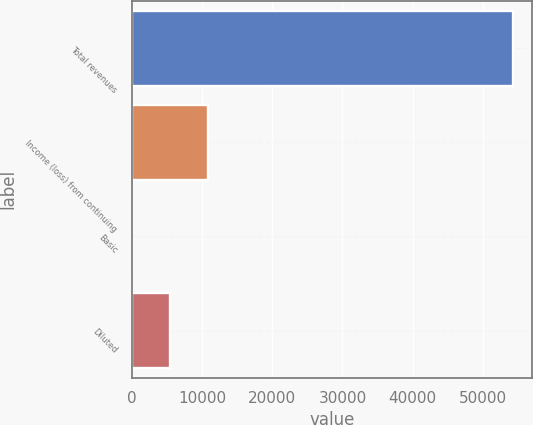<chart> <loc_0><loc_0><loc_500><loc_500><bar_chart><fcel>Total revenues<fcel>Income (loss) from continuing<fcel>Basic<fcel>Diluted<nl><fcel>54282<fcel>10857.4<fcel>1.29<fcel>5429.36<nl></chart> 